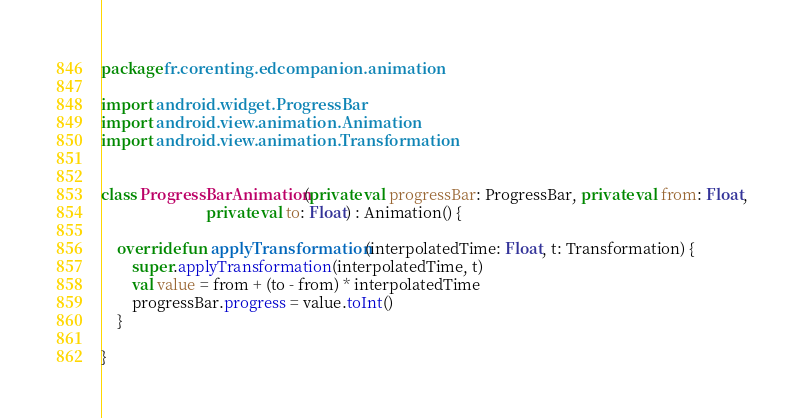Convert code to text. <code><loc_0><loc_0><loc_500><loc_500><_Kotlin_>package fr.corenting.edcompanion.animation

import android.widget.ProgressBar
import android.view.animation.Animation
import android.view.animation.Transformation


class ProgressBarAnimation(private val progressBar: ProgressBar, private val from: Float,
                           private val to: Float) : Animation() {

    override fun applyTransformation(interpolatedTime: Float, t: Transformation) {
        super.applyTransformation(interpolatedTime, t)
        val value = from + (to - from) * interpolatedTime
        progressBar.progress = value.toInt()
    }

}</code> 